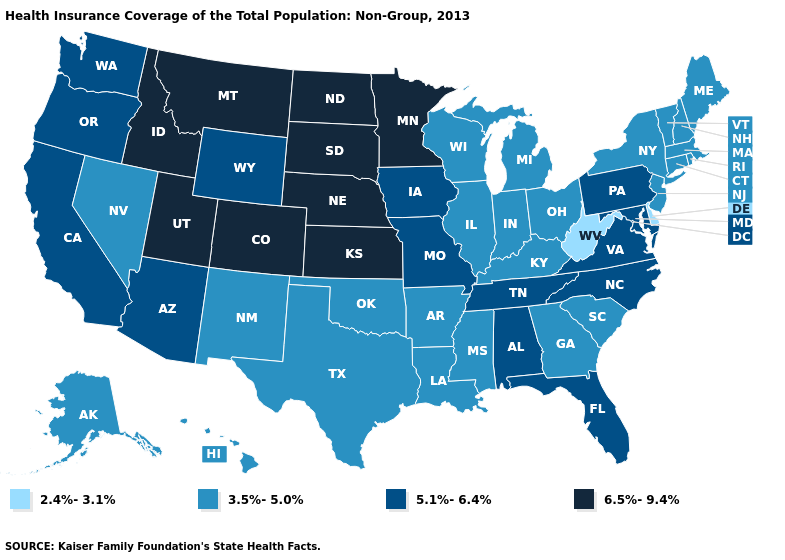Does the map have missing data?
Write a very short answer. No. What is the value of Maryland?
Concise answer only. 5.1%-6.4%. How many symbols are there in the legend?
Be succinct. 4. What is the lowest value in states that border Tennessee?
Be succinct. 3.5%-5.0%. Name the states that have a value in the range 2.4%-3.1%?
Quick response, please. Delaware, West Virginia. What is the value of Arkansas?
Answer briefly. 3.5%-5.0%. What is the highest value in the South ?
Quick response, please. 5.1%-6.4%. Which states have the highest value in the USA?
Keep it brief. Colorado, Idaho, Kansas, Minnesota, Montana, Nebraska, North Dakota, South Dakota, Utah. Which states have the lowest value in the USA?
Be succinct. Delaware, West Virginia. Does Missouri have the lowest value in the MidWest?
Answer briefly. No. Among the states that border Arkansas , does Mississippi have the lowest value?
Write a very short answer. Yes. Which states hav the highest value in the MidWest?
Give a very brief answer. Kansas, Minnesota, Nebraska, North Dakota, South Dakota. What is the value of Texas?
Give a very brief answer. 3.5%-5.0%. Does New Jersey have the same value as Rhode Island?
Short answer required. Yes. Does Illinois have the highest value in the MidWest?
Short answer required. No. 